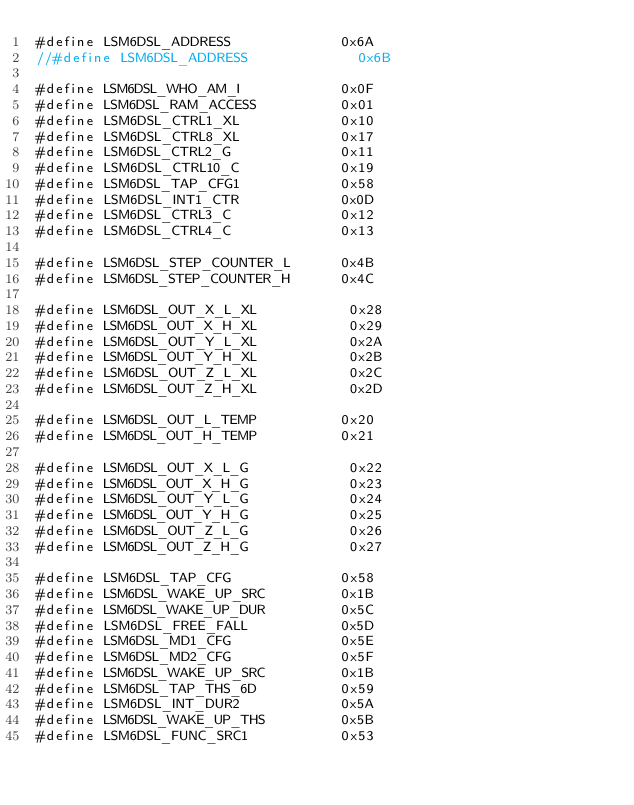<code> <loc_0><loc_0><loc_500><loc_500><_C_>#define LSM6DSL_ADDRESS             0x6A
//#define LSM6DSL_ADDRESS             0x6B                                                     

#define LSM6DSL_WHO_AM_I            0x0F
#define LSM6DSL_RAM_ACCESS          0x01
#define LSM6DSL_CTRL1_XL            0x10
#define LSM6DSL_CTRL8_XL            0x17
#define LSM6DSL_CTRL2_G             0x11
#define LSM6DSL_CTRL10_C            0x19
#define LSM6DSL_TAP_CFG1            0x58
#define LSM6DSL_INT1_CTR            0x0D
#define LSM6DSL_CTRL3_C             0x12
#define LSM6DSL_CTRL4_C             0x13

#define LSM6DSL_STEP_COUNTER_L      0x4B
#define LSM6DSL_STEP_COUNTER_H      0x4C

#define LSM6DSL_OUT_X_L_XL           0x28
#define LSM6DSL_OUT_X_H_XL           0x29
#define LSM6DSL_OUT_Y_L_XL           0x2A
#define LSM6DSL_OUT_Y_H_XL           0x2B
#define LSM6DSL_OUT_Z_L_XL           0x2C
#define LSM6DSL_OUT_Z_H_XL           0x2D

#define LSM6DSL_OUT_L_TEMP          0x20
#define LSM6DSL_OUT_H_TEMP          0x21

#define LSM6DSL_OUT_X_L_G            0x22
#define LSM6DSL_OUT_X_H_G            0x23
#define LSM6DSL_OUT_Y_L_G            0x24
#define LSM6DSL_OUT_Y_H_G            0x25
#define LSM6DSL_OUT_Z_L_G            0x26
#define LSM6DSL_OUT_Z_H_G            0x27

#define LSM6DSL_TAP_CFG             0x58
#define LSM6DSL_WAKE_UP_SRC         0x1B
#define LSM6DSL_WAKE_UP_DUR         0x5C
#define LSM6DSL_FREE_FALL           0x5D
#define LSM6DSL_MD1_CFG             0x5E
#define LSM6DSL_MD2_CFG             0x5F
#define LSM6DSL_WAKE_UP_SRC         0x1B
#define LSM6DSL_TAP_THS_6D          0x59
#define LSM6DSL_INT_DUR2            0x5A
#define LSM6DSL_WAKE_UP_THS         0x5B
#define LSM6DSL_FUNC_SRC1           0x53
</code> 